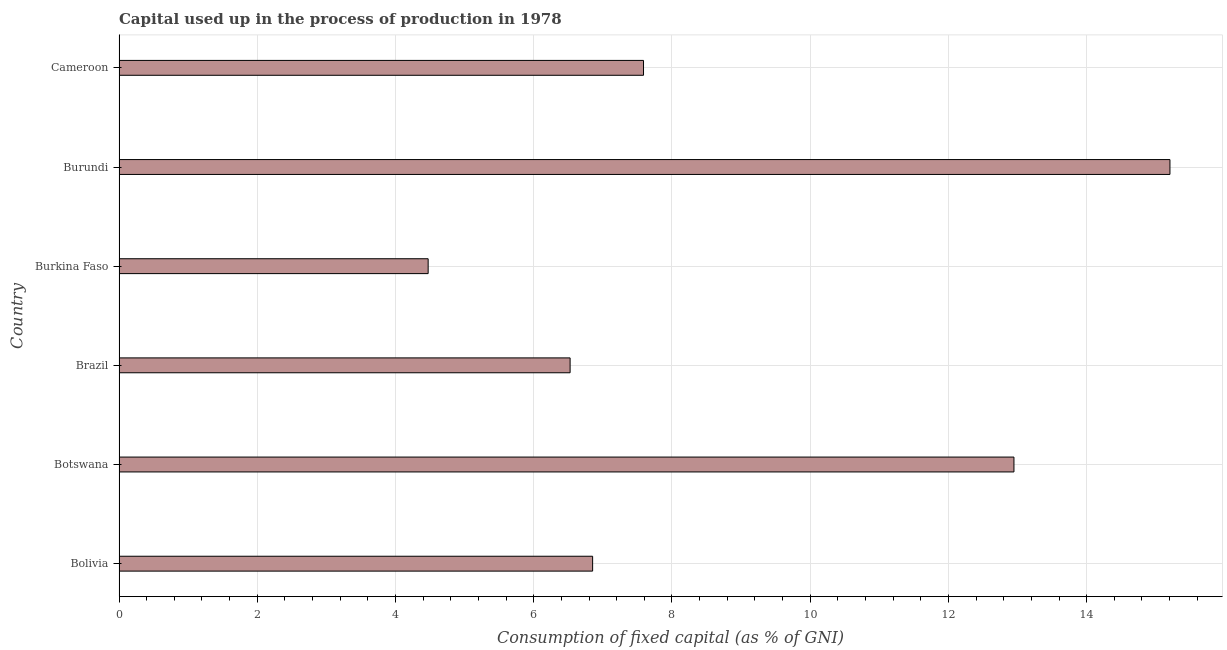What is the title of the graph?
Your answer should be very brief. Capital used up in the process of production in 1978. What is the label or title of the X-axis?
Make the answer very short. Consumption of fixed capital (as % of GNI). What is the label or title of the Y-axis?
Ensure brevity in your answer.  Country. What is the consumption of fixed capital in Burkina Faso?
Keep it short and to the point. 4.47. Across all countries, what is the maximum consumption of fixed capital?
Provide a short and direct response. 15.2. Across all countries, what is the minimum consumption of fixed capital?
Give a very brief answer. 4.47. In which country was the consumption of fixed capital maximum?
Offer a very short reply. Burundi. In which country was the consumption of fixed capital minimum?
Your answer should be compact. Burkina Faso. What is the sum of the consumption of fixed capital?
Provide a succinct answer. 53.59. What is the difference between the consumption of fixed capital in Brazil and Cameroon?
Provide a short and direct response. -1.06. What is the average consumption of fixed capital per country?
Provide a succinct answer. 8.93. What is the median consumption of fixed capital?
Make the answer very short. 7.22. What is the ratio of the consumption of fixed capital in Bolivia to that in Cameroon?
Your answer should be very brief. 0.9. Is the difference between the consumption of fixed capital in Brazil and Burundi greater than the difference between any two countries?
Make the answer very short. No. What is the difference between the highest and the second highest consumption of fixed capital?
Provide a short and direct response. 2.26. Is the sum of the consumption of fixed capital in Botswana and Cameroon greater than the maximum consumption of fixed capital across all countries?
Offer a very short reply. Yes. What is the difference between the highest and the lowest consumption of fixed capital?
Your response must be concise. 10.73. How many bars are there?
Your answer should be compact. 6. Are all the bars in the graph horizontal?
Offer a terse response. Yes. How many countries are there in the graph?
Your response must be concise. 6. What is the Consumption of fixed capital (as % of GNI) in Bolivia?
Provide a short and direct response. 6.85. What is the Consumption of fixed capital (as % of GNI) of Botswana?
Give a very brief answer. 12.95. What is the Consumption of fixed capital (as % of GNI) of Brazil?
Provide a succinct answer. 6.53. What is the Consumption of fixed capital (as % of GNI) of Burkina Faso?
Your answer should be compact. 4.47. What is the Consumption of fixed capital (as % of GNI) in Burundi?
Offer a terse response. 15.2. What is the Consumption of fixed capital (as % of GNI) of Cameroon?
Make the answer very short. 7.59. What is the difference between the Consumption of fixed capital (as % of GNI) in Bolivia and Botswana?
Ensure brevity in your answer.  -6.1. What is the difference between the Consumption of fixed capital (as % of GNI) in Bolivia and Brazil?
Your answer should be very brief. 0.33. What is the difference between the Consumption of fixed capital (as % of GNI) in Bolivia and Burkina Faso?
Your response must be concise. 2.38. What is the difference between the Consumption of fixed capital (as % of GNI) in Bolivia and Burundi?
Make the answer very short. -8.35. What is the difference between the Consumption of fixed capital (as % of GNI) in Bolivia and Cameroon?
Give a very brief answer. -0.74. What is the difference between the Consumption of fixed capital (as % of GNI) in Botswana and Brazil?
Your answer should be very brief. 6.42. What is the difference between the Consumption of fixed capital (as % of GNI) in Botswana and Burkina Faso?
Keep it short and to the point. 8.48. What is the difference between the Consumption of fixed capital (as % of GNI) in Botswana and Burundi?
Your response must be concise. -2.26. What is the difference between the Consumption of fixed capital (as % of GNI) in Botswana and Cameroon?
Ensure brevity in your answer.  5.36. What is the difference between the Consumption of fixed capital (as % of GNI) in Brazil and Burkina Faso?
Offer a terse response. 2.05. What is the difference between the Consumption of fixed capital (as % of GNI) in Brazil and Burundi?
Give a very brief answer. -8.68. What is the difference between the Consumption of fixed capital (as % of GNI) in Brazil and Cameroon?
Offer a very short reply. -1.06. What is the difference between the Consumption of fixed capital (as % of GNI) in Burkina Faso and Burundi?
Your response must be concise. -10.73. What is the difference between the Consumption of fixed capital (as % of GNI) in Burkina Faso and Cameroon?
Your answer should be compact. -3.12. What is the difference between the Consumption of fixed capital (as % of GNI) in Burundi and Cameroon?
Keep it short and to the point. 7.62. What is the ratio of the Consumption of fixed capital (as % of GNI) in Bolivia to that in Botswana?
Your response must be concise. 0.53. What is the ratio of the Consumption of fixed capital (as % of GNI) in Bolivia to that in Burkina Faso?
Your answer should be very brief. 1.53. What is the ratio of the Consumption of fixed capital (as % of GNI) in Bolivia to that in Burundi?
Provide a short and direct response. 0.45. What is the ratio of the Consumption of fixed capital (as % of GNI) in Bolivia to that in Cameroon?
Your answer should be compact. 0.9. What is the ratio of the Consumption of fixed capital (as % of GNI) in Botswana to that in Brazil?
Offer a very short reply. 1.98. What is the ratio of the Consumption of fixed capital (as % of GNI) in Botswana to that in Burkina Faso?
Make the answer very short. 2.9. What is the ratio of the Consumption of fixed capital (as % of GNI) in Botswana to that in Burundi?
Ensure brevity in your answer.  0.85. What is the ratio of the Consumption of fixed capital (as % of GNI) in Botswana to that in Cameroon?
Your response must be concise. 1.71. What is the ratio of the Consumption of fixed capital (as % of GNI) in Brazil to that in Burkina Faso?
Give a very brief answer. 1.46. What is the ratio of the Consumption of fixed capital (as % of GNI) in Brazil to that in Burundi?
Your answer should be very brief. 0.43. What is the ratio of the Consumption of fixed capital (as % of GNI) in Brazil to that in Cameroon?
Your response must be concise. 0.86. What is the ratio of the Consumption of fixed capital (as % of GNI) in Burkina Faso to that in Burundi?
Your answer should be compact. 0.29. What is the ratio of the Consumption of fixed capital (as % of GNI) in Burkina Faso to that in Cameroon?
Your answer should be very brief. 0.59. What is the ratio of the Consumption of fixed capital (as % of GNI) in Burundi to that in Cameroon?
Provide a succinct answer. 2. 